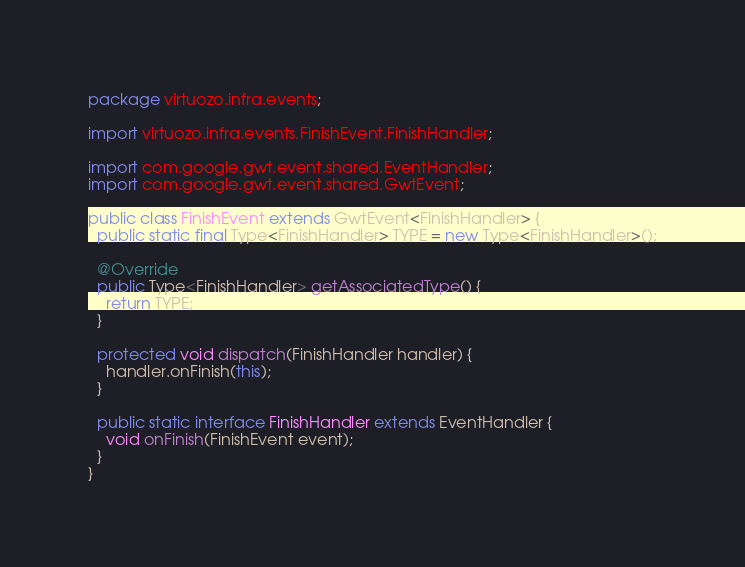Convert code to text. <code><loc_0><loc_0><loc_500><loc_500><_Java_>package virtuozo.infra.events;

import virtuozo.infra.events.FinishEvent.FinishHandler;

import com.google.gwt.event.shared.EventHandler;
import com.google.gwt.event.shared.GwtEvent;

public class FinishEvent extends GwtEvent<FinishHandler> {
  public static final Type<FinishHandler> TYPE = new Type<FinishHandler>();

  @Override
  public Type<FinishHandler> getAssociatedType() {
    return TYPE;
  }

  protected void dispatch(FinishHandler handler) {
    handler.onFinish(this);
  }

  public static interface FinishHandler extends EventHandler {
    void onFinish(FinishEvent event);
  }
}</code> 